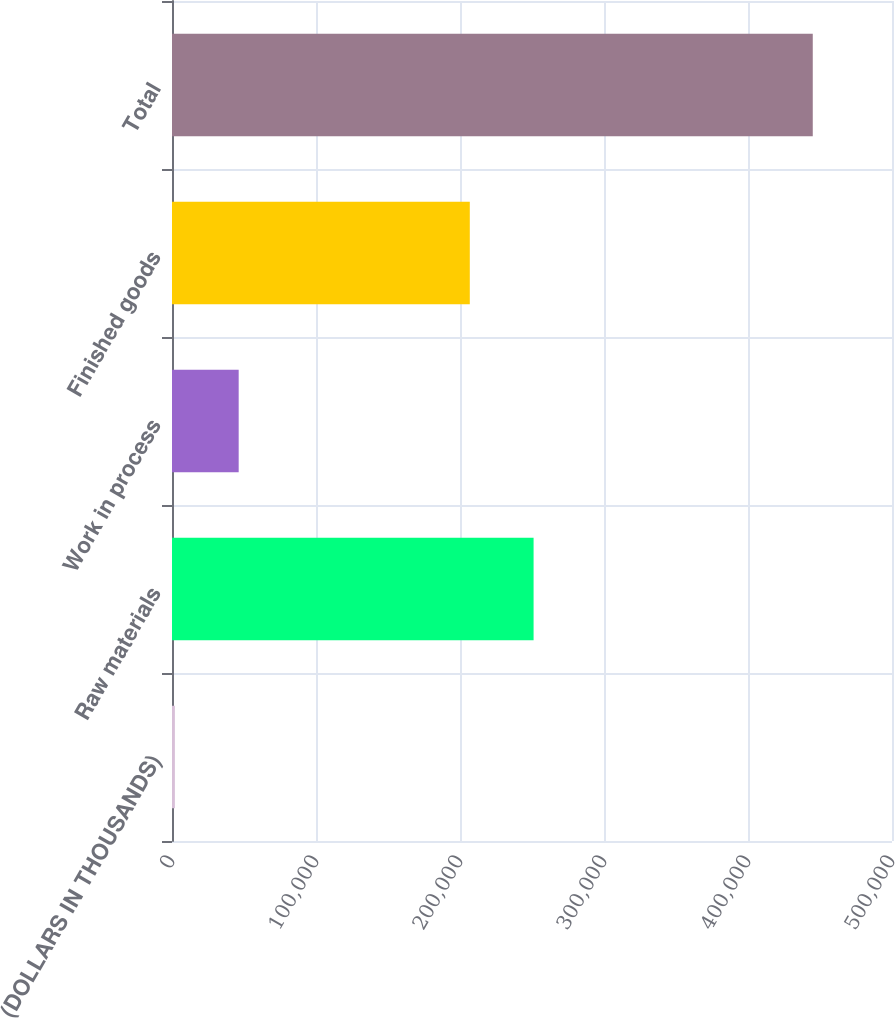Convert chart. <chart><loc_0><loc_0><loc_500><loc_500><bar_chart><fcel>(DOLLARS IN THOUSANDS)<fcel>Raw materials<fcel>Work in process<fcel>Finished goods<fcel>Total<nl><fcel>2009<fcel>251102<fcel>46305.8<fcel>206805<fcel>444977<nl></chart> 